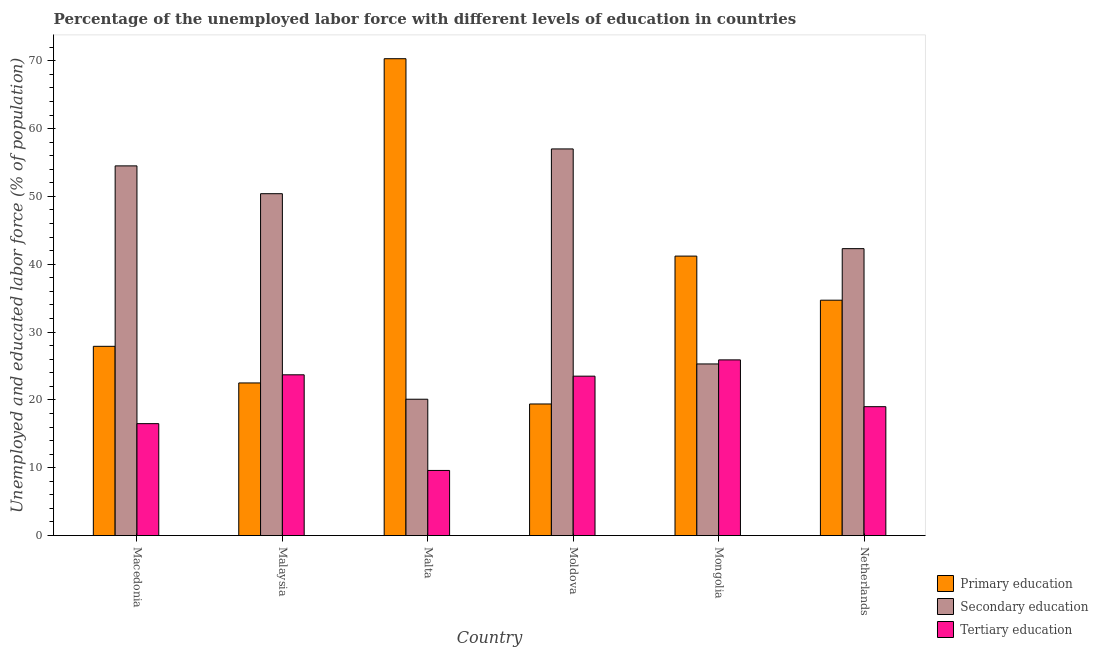How many bars are there on the 3rd tick from the left?
Make the answer very short. 3. What is the label of the 2nd group of bars from the left?
Keep it short and to the point. Malaysia. What is the percentage of labor force who received tertiary education in Malaysia?
Make the answer very short. 23.7. Across all countries, what is the maximum percentage of labor force who received primary education?
Provide a short and direct response. 70.3. Across all countries, what is the minimum percentage of labor force who received primary education?
Your answer should be compact. 19.4. In which country was the percentage of labor force who received tertiary education maximum?
Ensure brevity in your answer.  Mongolia. In which country was the percentage of labor force who received primary education minimum?
Offer a terse response. Moldova. What is the total percentage of labor force who received secondary education in the graph?
Provide a succinct answer. 249.6. What is the difference between the percentage of labor force who received primary education in Macedonia and that in Moldova?
Give a very brief answer. 8.5. What is the difference between the percentage of labor force who received primary education in Moldova and the percentage of labor force who received tertiary education in Malta?
Keep it short and to the point. 9.8. What is the average percentage of labor force who received tertiary education per country?
Your response must be concise. 19.7. What is the difference between the percentage of labor force who received primary education and percentage of labor force who received secondary education in Macedonia?
Your response must be concise. -26.6. In how many countries, is the percentage of labor force who received secondary education greater than 46 %?
Offer a very short reply. 3. What is the ratio of the percentage of labor force who received secondary education in Malaysia to that in Malta?
Offer a terse response. 2.51. Is the percentage of labor force who received tertiary education in Malaysia less than that in Malta?
Provide a succinct answer. No. What is the difference between the highest and the second highest percentage of labor force who received secondary education?
Make the answer very short. 2.5. What is the difference between the highest and the lowest percentage of labor force who received primary education?
Offer a terse response. 50.9. What does the 1st bar from the left in Mongolia represents?
Offer a very short reply. Primary education. What does the 1st bar from the right in Netherlands represents?
Ensure brevity in your answer.  Tertiary education. Does the graph contain grids?
Your answer should be very brief. No. Where does the legend appear in the graph?
Make the answer very short. Bottom right. How are the legend labels stacked?
Make the answer very short. Vertical. What is the title of the graph?
Your answer should be very brief. Percentage of the unemployed labor force with different levels of education in countries. What is the label or title of the X-axis?
Offer a very short reply. Country. What is the label or title of the Y-axis?
Ensure brevity in your answer.  Unemployed and educated labor force (% of population). What is the Unemployed and educated labor force (% of population) of Primary education in Macedonia?
Offer a terse response. 27.9. What is the Unemployed and educated labor force (% of population) in Secondary education in Macedonia?
Provide a succinct answer. 54.5. What is the Unemployed and educated labor force (% of population) in Tertiary education in Macedonia?
Offer a terse response. 16.5. What is the Unemployed and educated labor force (% of population) of Primary education in Malaysia?
Provide a short and direct response. 22.5. What is the Unemployed and educated labor force (% of population) in Secondary education in Malaysia?
Your response must be concise. 50.4. What is the Unemployed and educated labor force (% of population) of Tertiary education in Malaysia?
Offer a very short reply. 23.7. What is the Unemployed and educated labor force (% of population) in Primary education in Malta?
Ensure brevity in your answer.  70.3. What is the Unemployed and educated labor force (% of population) in Secondary education in Malta?
Make the answer very short. 20.1. What is the Unemployed and educated labor force (% of population) of Tertiary education in Malta?
Provide a succinct answer. 9.6. What is the Unemployed and educated labor force (% of population) in Primary education in Moldova?
Give a very brief answer. 19.4. What is the Unemployed and educated labor force (% of population) in Tertiary education in Moldova?
Your answer should be very brief. 23.5. What is the Unemployed and educated labor force (% of population) in Primary education in Mongolia?
Your response must be concise. 41.2. What is the Unemployed and educated labor force (% of population) in Secondary education in Mongolia?
Offer a very short reply. 25.3. What is the Unemployed and educated labor force (% of population) in Tertiary education in Mongolia?
Give a very brief answer. 25.9. What is the Unemployed and educated labor force (% of population) in Primary education in Netherlands?
Your answer should be very brief. 34.7. What is the Unemployed and educated labor force (% of population) in Secondary education in Netherlands?
Provide a succinct answer. 42.3. Across all countries, what is the maximum Unemployed and educated labor force (% of population) of Primary education?
Make the answer very short. 70.3. Across all countries, what is the maximum Unemployed and educated labor force (% of population) in Tertiary education?
Ensure brevity in your answer.  25.9. Across all countries, what is the minimum Unemployed and educated labor force (% of population) in Primary education?
Ensure brevity in your answer.  19.4. Across all countries, what is the minimum Unemployed and educated labor force (% of population) in Secondary education?
Provide a short and direct response. 20.1. Across all countries, what is the minimum Unemployed and educated labor force (% of population) in Tertiary education?
Offer a very short reply. 9.6. What is the total Unemployed and educated labor force (% of population) of Primary education in the graph?
Provide a succinct answer. 216. What is the total Unemployed and educated labor force (% of population) of Secondary education in the graph?
Offer a terse response. 249.6. What is the total Unemployed and educated labor force (% of population) in Tertiary education in the graph?
Provide a short and direct response. 118.2. What is the difference between the Unemployed and educated labor force (% of population) in Primary education in Macedonia and that in Malta?
Provide a succinct answer. -42.4. What is the difference between the Unemployed and educated labor force (% of population) of Secondary education in Macedonia and that in Malta?
Your response must be concise. 34.4. What is the difference between the Unemployed and educated labor force (% of population) of Tertiary education in Macedonia and that in Malta?
Provide a short and direct response. 6.9. What is the difference between the Unemployed and educated labor force (% of population) in Secondary education in Macedonia and that in Moldova?
Make the answer very short. -2.5. What is the difference between the Unemployed and educated labor force (% of population) of Primary education in Macedonia and that in Mongolia?
Make the answer very short. -13.3. What is the difference between the Unemployed and educated labor force (% of population) of Secondary education in Macedonia and that in Mongolia?
Your response must be concise. 29.2. What is the difference between the Unemployed and educated labor force (% of population) in Primary education in Macedonia and that in Netherlands?
Your response must be concise. -6.8. What is the difference between the Unemployed and educated labor force (% of population) in Secondary education in Macedonia and that in Netherlands?
Keep it short and to the point. 12.2. What is the difference between the Unemployed and educated labor force (% of population) in Primary education in Malaysia and that in Malta?
Your answer should be compact. -47.8. What is the difference between the Unemployed and educated labor force (% of population) of Secondary education in Malaysia and that in Malta?
Give a very brief answer. 30.3. What is the difference between the Unemployed and educated labor force (% of population) in Tertiary education in Malaysia and that in Malta?
Keep it short and to the point. 14.1. What is the difference between the Unemployed and educated labor force (% of population) in Primary education in Malaysia and that in Moldova?
Your response must be concise. 3.1. What is the difference between the Unemployed and educated labor force (% of population) in Secondary education in Malaysia and that in Moldova?
Make the answer very short. -6.6. What is the difference between the Unemployed and educated labor force (% of population) in Primary education in Malaysia and that in Mongolia?
Make the answer very short. -18.7. What is the difference between the Unemployed and educated labor force (% of population) of Secondary education in Malaysia and that in Mongolia?
Offer a terse response. 25.1. What is the difference between the Unemployed and educated labor force (% of population) in Tertiary education in Malaysia and that in Mongolia?
Keep it short and to the point. -2.2. What is the difference between the Unemployed and educated labor force (% of population) in Primary education in Malaysia and that in Netherlands?
Your response must be concise. -12.2. What is the difference between the Unemployed and educated labor force (% of population) of Secondary education in Malaysia and that in Netherlands?
Your answer should be compact. 8.1. What is the difference between the Unemployed and educated labor force (% of population) in Primary education in Malta and that in Moldova?
Your response must be concise. 50.9. What is the difference between the Unemployed and educated labor force (% of population) in Secondary education in Malta and that in Moldova?
Provide a succinct answer. -36.9. What is the difference between the Unemployed and educated labor force (% of population) of Tertiary education in Malta and that in Moldova?
Keep it short and to the point. -13.9. What is the difference between the Unemployed and educated labor force (% of population) of Primary education in Malta and that in Mongolia?
Keep it short and to the point. 29.1. What is the difference between the Unemployed and educated labor force (% of population) of Tertiary education in Malta and that in Mongolia?
Provide a succinct answer. -16.3. What is the difference between the Unemployed and educated labor force (% of population) of Primary education in Malta and that in Netherlands?
Provide a short and direct response. 35.6. What is the difference between the Unemployed and educated labor force (% of population) in Secondary education in Malta and that in Netherlands?
Keep it short and to the point. -22.2. What is the difference between the Unemployed and educated labor force (% of population) in Primary education in Moldova and that in Mongolia?
Provide a succinct answer. -21.8. What is the difference between the Unemployed and educated labor force (% of population) in Secondary education in Moldova and that in Mongolia?
Give a very brief answer. 31.7. What is the difference between the Unemployed and educated labor force (% of population) of Tertiary education in Moldova and that in Mongolia?
Provide a succinct answer. -2.4. What is the difference between the Unemployed and educated labor force (% of population) of Primary education in Moldova and that in Netherlands?
Provide a short and direct response. -15.3. What is the difference between the Unemployed and educated labor force (% of population) in Secondary education in Moldova and that in Netherlands?
Make the answer very short. 14.7. What is the difference between the Unemployed and educated labor force (% of population) in Primary education in Mongolia and that in Netherlands?
Provide a short and direct response. 6.5. What is the difference between the Unemployed and educated labor force (% of population) of Tertiary education in Mongolia and that in Netherlands?
Give a very brief answer. 6.9. What is the difference between the Unemployed and educated labor force (% of population) in Primary education in Macedonia and the Unemployed and educated labor force (% of population) in Secondary education in Malaysia?
Provide a succinct answer. -22.5. What is the difference between the Unemployed and educated labor force (% of population) of Secondary education in Macedonia and the Unemployed and educated labor force (% of population) of Tertiary education in Malaysia?
Offer a very short reply. 30.8. What is the difference between the Unemployed and educated labor force (% of population) of Primary education in Macedonia and the Unemployed and educated labor force (% of population) of Tertiary education in Malta?
Provide a short and direct response. 18.3. What is the difference between the Unemployed and educated labor force (% of population) in Secondary education in Macedonia and the Unemployed and educated labor force (% of population) in Tertiary education in Malta?
Your response must be concise. 44.9. What is the difference between the Unemployed and educated labor force (% of population) of Primary education in Macedonia and the Unemployed and educated labor force (% of population) of Secondary education in Moldova?
Make the answer very short. -29.1. What is the difference between the Unemployed and educated labor force (% of population) in Primary education in Macedonia and the Unemployed and educated labor force (% of population) in Tertiary education in Moldova?
Keep it short and to the point. 4.4. What is the difference between the Unemployed and educated labor force (% of population) in Secondary education in Macedonia and the Unemployed and educated labor force (% of population) in Tertiary education in Mongolia?
Give a very brief answer. 28.6. What is the difference between the Unemployed and educated labor force (% of population) in Primary education in Macedonia and the Unemployed and educated labor force (% of population) in Secondary education in Netherlands?
Ensure brevity in your answer.  -14.4. What is the difference between the Unemployed and educated labor force (% of population) of Secondary education in Macedonia and the Unemployed and educated labor force (% of population) of Tertiary education in Netherlands?
Your answer should be very brief. 35.5. What is the difference between the Unemployed and educated labor force (% of population) of Primary education in Malaysia and the Unemployed and educated labor force (% of population) of Secondary education in Malta?
Keep it short and to the point. 2.4. What is the difference between the Unemployed and educated labor force (% of population) of Secondary education in Malaysia and the Unemployed and educated labor force (% of population) of Tertiary education in Malta?
Offer a very short reply. 40.8. What is the difference between the Unemployed and educated labor force (% of population) of Primary education in Malaysia and the Unemployed and educated labor force (% of population) of Secondary education in Moldova?
Your answer should be compact. -34.5. What is the difference between the Unemployed and educated labor force (% of population) of Primary education in Malaysia and the Unemployed and educated labor force (% of population) of Tertiary education in Moldova?
Offer a very short reply. -1. What is the difference between the Unemployed and educated labor force (% of population) in Secondary education in Malaysia and the Unemployed and educated labor force (% of population) in Tertiary education in Moldova?
Your answer should be very brief. 26.9. What is the difference between the Unemployed and educated labor force (% of population) of Primary education in Malaysia and the Unemployed and educated labor force (% of population) of Secondary education in Mongolia?
Offer a terse response. -2.8. What is the difference between the Unemployed and educated labor force (% of population) of Primary education in Malaysia and the Unemployed and educated labor force (% of population) of Secondary education in Netherlands?
Make the answer very short. -19.8. What is the difference between the Unemployed and educated labor force (% of population) of Primary education in Malaysia and the Unemployed and educated labor force (% of population) of Tertiary education in Netherlands?
Make the answer very short. 3.5. What is the difference between the Unemployed and educated labor force (% of population) of Secondary education in Malaysia and the Unemployed and educated labor force (% of population) of Tertiary education in Netherlands?
Your response must be concise. 31.4. What is the difference between the Unemployed and educated labor force (% of population) in Primary education in Malta and the Unemployed and educated labor force (% of population) in Tertiary education in Moldova?
Offer a very short reply. 46.8. What is the difference between the Unemployed and educated labor force (% of population) of Secondary education in Malta and the Unemployed and educated labor force (% of population) of Tertiary education in Moldova?
Keep it short and to the point. -3.4. What is the difference between the Unemployed and educated labor force (% of population) of Primary education in Malta and the Unemployed and educated labor force (% of population) of Secondary education in Mongolia?
Your response must be concise. 45. What is the difference between the Unemployed and educated labor force (% of population) in Primary education in Malta and the Unemployed and educated labor force (% of population) in Tertiary education in Mongolia?
Keep it short and to the point. 44.4. What is the difference between the Unemployed and educated labor force (% of population) of Primary education in Malta and the Unemployed and educated labor force (% of population) of Secondary education in Netherlands?
Provide a short and direct response. 28. What is the difference between the Unemployed and educated labor force (% of population) in Primary education in Malta and the Unemployed and educated labor force (% of population) in Tertiary education in Netherlands?
Your answer should be very brief. 51.3. What is the difference between the Unemployed and educated labor force (% of population) in Secondary education in Malta and the Unemployed and educated labor force (% of population) in Tertiary education in Netherlands?
Provide a succinct answer. 1.1. What is the difference between the Unemployed and educated labor force (% of population) in Secondary education in Moldova and the Unemployed and educated labor force (% of population) in Tertiary education in Mongolia?
Your answer should be very brief. 31.1. What is the difference between the Unemployed and educated labor force (% of population) of Primary education in Moldova and the Unemployed and educated labor force (% of population) of Secondary education in Netherlands?
Keep it short and to the point. -22.9. What is the difference between the Unemployed and educated labor force (% of population) of Primary education in Moldova and the Unemployed and educated labor force (% of population) of Tertiary education in Netherlands?
Provide a succinct answer. 0.4. What is the difference between the Unemployed and educated labor force (% of population) in Secondary education in Moldova and the Unemployed and educated labor force (% of population) in Tertiary education in Netherlands?
Keep it short and to the point. 38. What is the average Unemployed and educated labor force (% of population) of Secondary education per country?
Offer a very short reply. 41.6. What is the average Unemployed and educated labor force (% of population) of Tertiary education per country?
Your answer should be very brief. 19.7. What is the difference between the Unemployed and educated labor force (% of population) of Primary education and Unemployed and educated labor force (% of population) of Secondary education in Macedonia?
Offer a very short reply. -26.6. What is the difference between the Unemployed and educated labor force (% of population) of Secondary education and Unemployed and educated labor force (% of population) of Tertiary education in Macedonia?
Provide a succinct answer. 38. What is the difference between the Unemployed and educated labor force (% of population) in Primary education and Unemployed and educated labor force (% of population) in Secondary education in Malaysia?
Your answer should be very brief. -27.9. What is the difference between the Unemployed and educated labor force (% of population) of Primary education and Unemployed and educated labor force (% of population) of Tertiary education in Malaysia?
Make the answer very short. -1.2. What is the difference between the Unemployed and educated labor force (% of population) of Secondary education and Unemployed and educated labor force (% of population) of Tertiary education in Malaysia?
Give a very brief answer. 26.7. What is the difference between the Unemployed and educated labor force (% of population) in Primary education and Unemployed and educated labor force (% of population) in Secondary education in Malta?
Provide a short and direct response. 50.2. What is the difference between the Unemployed and educated labor force (% of population) in Primary education and Unemployed and educated labor force (% of population) in Tertiary education in Malta?
Your answer should be compact. 60.7. What is the difference between the Unemployed and educated labor force (% of population) of Primary education and Unemployed and educated labor force (% of population) of Secondary education in Moldova?
Offer a terse response. -37.6. What is the difference between the Unemployed and educated labor force (% of population) of Secondary education and Unemployed and educated labor force (% of population) of Tertiary education in Moldova?
Provide a succinct answer. 33.5. What is the difference between the Unemployed and educated labor force (% of population) of Secondary education and Unemployed and educated labor force (% of population) of Tertiary education in Mongolia?
Your answer should be compact. -0.6. What is the difference between the Unemployed and educated labor force (% of population) of Secondary education and Unemployed and educated labor force (% of population) of Tertiary education in Netherlands?
Offer a very short reply. 23.3. What is the ratio of the Unemployed and educated labor force (% of population) in Primary education in Macedonia to that in Malaysia?
Offer a terse response. 1.24. What is the ratio of the Unemployed and educated labor force (% of population) of Secondary education in Macedonia to that in Malaysia?
Give a very brief answer. 1.08. What is the ratio of the Unemployed and educated labor force (% of population) in Tertiary education in Macedonia to that in Malaysia?
Provide a succinct answer. 0.7. What is the ratio of the Unemployed and educated labor force (% of population) in Primary education in Macedonia to that in Malta?
Offer a terse response. 0.4. What is the ratio of the Unemployed and educated labor force (% of population) in Secondary education in Macedonia to that in Malta?
Provide a succinct answer. 2.71. What is the ratio of the Unemployed and educated labor force (% of population) in Tertiary education in Macedonia to that in Malta?
Your answer should be compact. 1.72. What is the ratio of the Unemployed and educated labor force (% of population) in Primary education in Macedonia to that in Moldova?
Your response must be concise. 1.44. What is the ratio of the Unemployed and educated labor force (% of population) of Secondary education in Macedonia to that in Moldova?
Offer a very short reply. 0.96. What is the ratio of the Unemployed and educated labor force (% of population) of Tertiary education in Macedonia to that in Moldova?
Offer a terse response. 0.7. What is the ratio of the Unemployed and educated labor force (% of population) of Primary education in Macedonia to that in Mongolia?
Keep it short and to the point. 0.68. What is the ratio of the Unemployed and educated labor force (% of population) of Secondary education in Macedonia to that in Mongolia?
Make the answer very short. 2.15. What is the ratio of the Unemployed and educated labor force (% of population) of Tertiary education in Macedonia to that in Mongolia?
Provide a short and direct response. 0.64. What is the ratio of the Unemployed and educated labor force (% of population) of Primary education in Macedonia to that in Netherlands?
Your response must be concise. 0.8. What is the ratio of the Unemployed and educated labor force (% of population) in Secondary education in Macedonia to that in Netherlands?
Ensure brevity in your answer.  1.29. What is the ratio of the Unemployed and educated labor force (% of population) of Tertiary education in Macedonia to that in Netherlands?
Your answer should be compact. 0.87. What is the ratio of the Unemployed and educated labor force (% of population) of Primary education in Malaysia to that in Malta?
Provide a succinct answer. 0.32. What is the ratio of the Unemployed and educated labor force (% of population) in Secondary education in Malaysia to that in Malta?
Make the answer very short. 2.51. What is the ratio of the Unemployed and educated labor force (% of population) of Tertiary education in Malaysia to that in Malta?
Your answer should be compact. 2.47. What is the ratio of the Unemployed and educated labor force (% of population) of Primary education in Malaysia to that in Moldova?
Your response must be concise. 1.16. What is the ratio of the Unemployed and educated labor force (% of population) in Secondary education in Malaysia to that in Moldova?
Offer a terse response. 0.88. What is the ratio of the Unemployed and educated labor force (% of population) in Tertiary education in Malaysia to that in Moldova?
Provide a succinct answer. 1.01. What is the ratio of the Unemployed and educated labor force (% of population) of Primary education in Malaysia to that in Mongolia?
Provide a succinct answer. 0.55. What is the ratio of the Unemployed and educated labor force (% of population) of Secondary education in Malaysia to that in Mongolia?
Make the answer very short. 1.99. What is the ratio of the Unemployed and educated labor force (% of population) of Tertiary education in Malaysia to that in Mongolia?
Ensure brevity in your answer.  0.92. What is the ratio of the Unemployed and educated labor force (% of population) in Primary education in Malaysia to that in Netherlands?
Keep it short and to the point. 0.65. What is the ratio of the Unemployed and educated labor force (% of population) of Secondary education in Malaysia to that in Netherlands?
Make the answer very short. 1.19. What is the ratio of the Unemployed and educated labor force (% of population) in Tertiary education in Malaysia to that in Netherlands?
Offer a very short reply. 1.25. What is the ratio of the Unemployed and educated labor force (% of population) of Primary education in Malta to that in Moldova?
Give a very brief answer. 3.62. What is the ratio of the Unemployed and educated labor force (% of population) in Secondary education in Malta to that in Moldova?
Provide a succinct answer. 0.35. What is the ratio of the Unemployed and educated labor force (% of population) of Tertiary education in Malta to that in Moldova?
Ensure brevity in your answer.  0.41. What is the ratio of the Unemployed and educated labor force (% of population) in Primary education in Malta to that in Mongolia?
Your answer should be very brief. 1.71. What is the ratio of the Unemployed and educated labor force (% of population) in Secondary education in Malta to that in Mongolia?
Provide a succinct answer. 0.79. What is the ratio of the Unemployed and educated labor force (% of population) of Tertiary education in Malta to that in Mongolia?
Your answer should be compact. 0.37. What is the ratio of the Unemployed and educated labor force (% of population) of Primary education in Malta to that in Netherlands?
Keep it short and to the point. 2.03. What is the ratio of the Unemployed and educated labor force (% of population) of Secondary education in Malta to that in Netherlands?
Offer a very short reply. 0.48. What is the ratio of the Unemployed and educated labor force (% of population) of Tertiary education in Malta to that in Netherlands?
Provide a succinct answer. 0.51. What is the ratio of the Unemployed and educated labor force (% of population) in Primary education in Moldova to that in Mongolia?
Offer a very short reply. 0.47. What is the ratio of the Unemployed and educated labor force (% of population) in Secondary education in Moldova to that in Mongolia?
Your answer should be very brief. 2.25. What is the ratio of the Unemployed and educated labor force (% of population) of Tertiary education in Moldova to that in Mongolia?
Offer a very short reply. 0.91. What is the ratio of the Unemployed and educated labor force (% of population) in Primary education in Moldova to that in Netherlands?
Make the answer very short. 0.56. What is the ratio of the Unemployed and educated labor force (% of population) in Secondary education in Moldova to that in Netherlands?
Offer a very short reply. 1.35. What is the ratio of the Unemployed and educated labor force (% of population) in Tertiary education in Moldova to that in Netherlands?
Provide a short and direct response. 1.24. What is the ratio of the Unemployed and educated labor force (% of population) of Primary education in Mongolia to that in Netherlands?
Ensure brevity in your answer.  1.19. What is the ratio of the Unemployed and educated labor force (% of population) in Secondary education in Mongolia to that in Netherlands?
Provide a short and direct response. 0.6. What is the ratio of the Unemployed and educated labor force (% of population) in Tertiary education in Mongolia to that in Netherlands?
Make the answer very short. 1.36. What is the difference between the highest and the second highest Unemployed and educated labor force (% of population) of Primary education?
Your response must be concise. 29.1. What is the difference between the highest and the second highest Unemployed and educated labor force (% of population) in Tertiary education?
Offer a terse response. 2.2. What is the difference between the highest and the lowest Unemployed and educated labor force (% of population) in Primary education?
Your answer should be compact. 50.9. What is the difference between the highest and the lowest Unemployed and educated labor force (% of population) in Secondary education?
Ensure brevity in your answer.  36.9. 